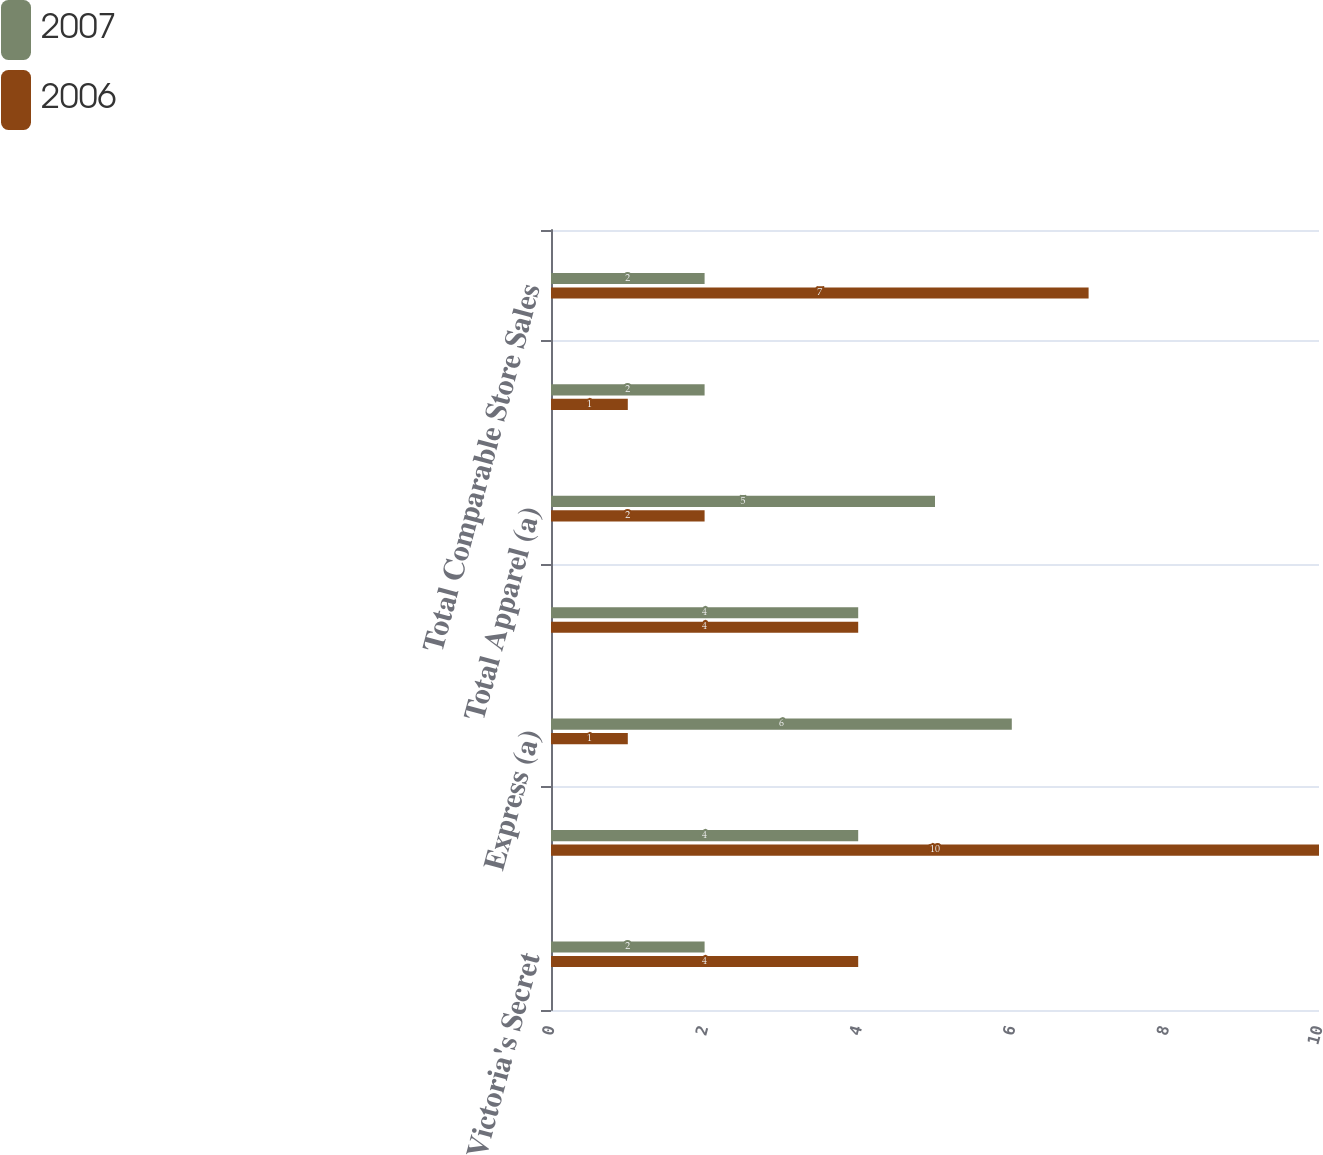<chart> <loc_0><loc_0><loc_500><loc_500><stacked_bar_chart><ecel><fcel>Victoria's Secret<fcel>Bath & Body Works<fcel>Express (a)<fcel>Limited Stores (a)<fcel>Total Apparel (a)<fcel>Henri Bendel<fcel>Total Comparable Store Sales<nl><fcel>2007<fcel>2<fcel>4<fcel>6<fcel>4<fcel>5<fcel>2<fcel>2<nl><fcel>2006<fcel>4<fcel>10<fcel>1<fcel>4<fcel>2<fcel>1<fcel>7<nl></chart> 